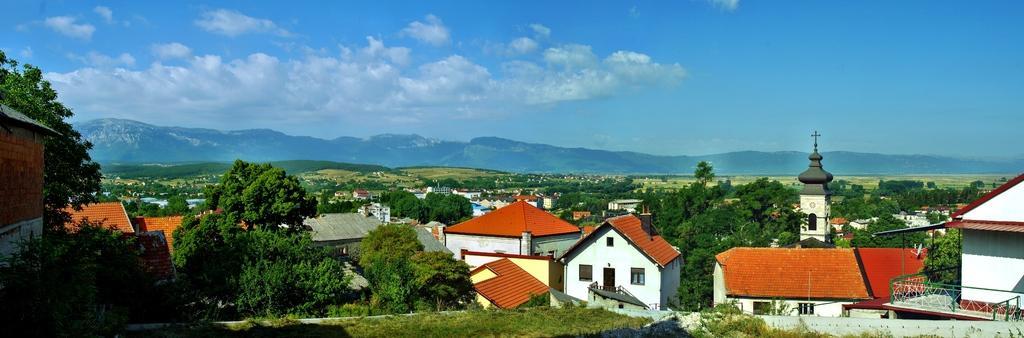How would you summarize this image in a sentence or two? These are the houses, on the right side there is a church and on the left side there are green color trees. At the top it's a sky. 